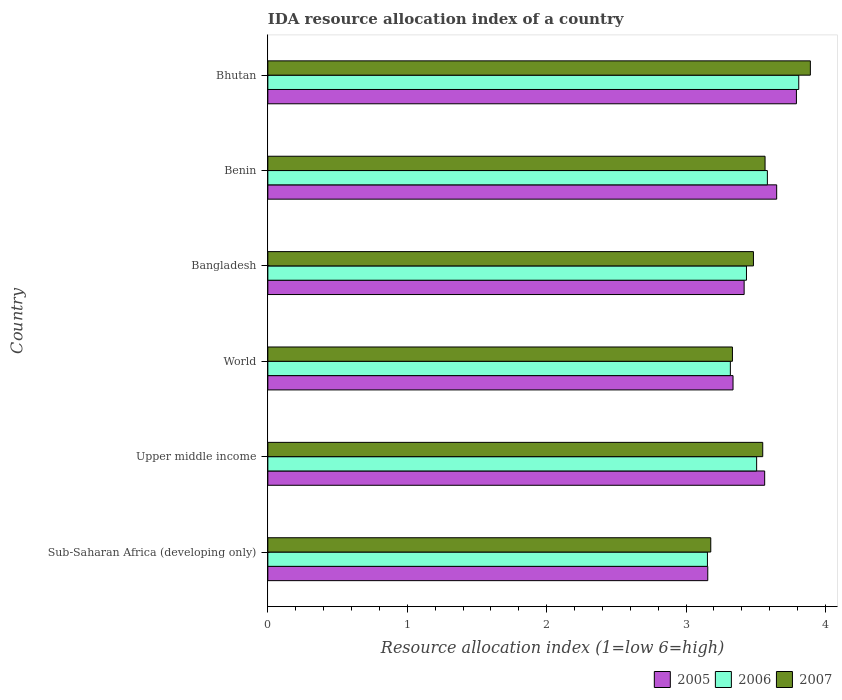Are the number of bars per tick equal to the number of legend labels?
Give a very brief answer. Yes. How many bars are there on the 5th tick from the top?
Make the answer very short. 3. How many bars are there on the 3rd tick from the bottom?
Give a very brief answer. 3. What is the label of the 5th group of bars from the top?
Make the answer very short. Upper middle income. In how many cases, is the number of bars for a given country not equal to the number of legend labels?
Give a very brief answer. 0. What is the IDA resource allocation index in 2006 in World?
Your response must be concise. 3.32. Across all countries, what is the maximum IDA resource allocation index in 2007?
Your answer should be very brief. 3.89. Across all countries, what is the minimum IDA resource allocation index in 2005?
Your response must be concise. 3.16. In which country was the IDA resource allocation index in 2007 maximum?
Your answer should be very brief. Bhutan. In which country was the IDA resource allocation index in 2005 minimum?
Provide a succinct answer. Sub-Saharan Africa (developing only). What is the total IDA resource allocation index in 2006 in the graph?
Provide a succinct answer. 20.8. What is the difference between the IDA resource allocation index in 2007 in Bhutan and that in Upper middle income?
Offer a terse response. 0.34. What is the difference between the IDA resource allocation index in 2005 in Benin and the IDA resource allocation index in 2007 in World?
Your answer should be very brief. 0.32. What is the average IDA resource allocation index in 2005 per country?
Your answer should be compact. 3.49. What is the difference between the IDA resource allocation index in 2006 and IDA resource allocation index in 2005 in Benin?
Provide a short and direct response. -0.07. What is the ratio of the IDA resource allocation index in 2007 in Bangladesh to that in Upper middle income?
Keep it short and to the point. 0.98. Is the IDA resource allocation index in 2005 in Bhutan less than that in World?
Provide a short and direct response. No. Is the difference between the IDA resource allocation index in 2006 in Benin and Bhutan greater than the difference between the IDA resource allocation index in 2005 in Benin and Bhutan?
Your response must be concise. No. What is the difference between the highest and the second highest IDA resource allocation index in 2006?
Your answer should be compact. 0.23. What is the difference between the highest and the lowest IDA resource allocation index in 2006?
Ensure brevity in your answer.  0.65. In how many countries, is the IDA resource allocation index in 2007 greater than the average IDA resource allocation index in 2007 taken over all countries?
Ensure brevity in your answer.  3. Is the sum of the IDA resource allocation index in 2007 in Sub-Saharan Africa (developing only) and Upper middle income greater than the maximum IDA resource allocation index in 2005 across all countries?
Keep it short and to the point. Yes. Is it the case that in every country, the sum of the IDA resource allocation index in 2005 and IDA resource allocation index in 2007 is greater than the IDA resource allocation index in 2006?
Keep it short and to the point. Yes. How many countries are there in the graph?
Provide a short and direct response. 6. Are the values on the major ticks of X-axis written in scientific E-notation?
Offer a very short reply. No. What is the title of the graph?
Your response must be concise. IDA resource allocation index of a country. What is the label or title of the X-axis?
Provide a succinct answer. Resource allocation index (1=low 6=high). What is the Resource allocation index (1=low 6=high) in 2005 in Sub-Saharan Africa (developing only)?
Your answer should be very brief. 3.16. What is the Resource allocation index (1=low 6=high) of 2006 in Sub-Saharan Africa (developing only)?
Provide a succinct answer. 3.15. What is the Resource allocation index (1=low 6=high) of 2007 in Sub-Saharan Africa (developing only)?
Offer a very short reply. 3.18. What is the Resource allocation index (1=low 6=high) of 2005 in Upper middle income?
Your answer should be compact. 3.56. What is the Resource allocation index (1=low 6=high) in 2006 in Upper middle income?
Ensure brevity in your answer.  3.51. What is the Resource allocation index (1=low 6=high) in 2007 in Upper middle income?
Offer a terse response. 3.55. What is the Resource allocation index (1=low 6=high) of 2005 in World?
Your answer should be compact. 3.34. What is the Resource allocation index (1=low 6=high) in 2006 in World?
Your answer should be very brief. 3.32. What is the Resource allocation index (1=low 6=high) of 2007 in World?
Your response must be concise. 3.33. What is the Resource allocation index (1=low 6=high) in 2005 in Bangladesh?
Make the answer very short. 3.42. What is the Resource allocation index (1=low 6=high) of 2006 in Bangladesh?
Provide a succinct answer. 3.43. What is the Resource allocation index (1=low 6=high) in 2007 in Bangladesh?
Your answer should be compact. 3.48. What is the Resource allocation index (1=low 6=high) of 2005 in Benin?
Give a very brief answer. 3.65. What is the Resource allocation index (1=low 6=high) of 2006 in Benin?
Your answer should be very brief. 3.58. What is the Resource allocation index (1=low 6=high) in 2007 in Benin?
Give a very brief answer. 3.57. What is the Resource allocation index (1=low 6=high) in 2005 in Bhutan?
Your response must be concise. 3.79. What is the Resource allocation index (1=low 6=high) of 2006 in Bhutan?
Your response must be concise. 3.81. What is the Resource allocation index (1=low 6=high) of 2007 in Bhutan?
Your answer should be compact. 3.89. Across all countries, what is the maximum Resource allocation index (1=low 6=high) in 2005?
Provide a succinct answer. 3.79. Across all countries, what is the maximum Resource allocation index (1=low 6=high) of 2006?
Offer a very short reply. 3.81. Across all countries, what is the maximum Resource allocation index (1=low 6=high) of 2007?
Keep it short and to the point. 3.89. Across all countries, what is the minimum Resource allocation index (1=low 6=high) in 2005?
Your answer should be compact. 3.16. Across all countries, what is the minimum Resource allocation index (1=low 6=high) in 2006?
Provide a short and direct response. 3.15. Across all countries, what is the minimum Resource allocation index (1=low 6=high) of 2007?
Offer a terse response. 3.18. What is the total Resource allocation index (1=low 6=high) of 2005 in the graph?
Offer a terse response. 20.91. What is the total Resource allocation index (1=low 6=high) in 2006 in the graph?
Ensure brevity in your answer.  20.8. What is the total Resource allocation index (1=low 6=high) in 2007 in the graph?
Offer a terse response. 21. What is the difference between the Resource allocation index (1=low 6=high) in 2005 in Sub-Saharan Africa (developing only) and that in Upper middle income?
Give a very brief answer. -0.41. What is the difference between the Resource allocation index (1=low 6=high) of 2006 in Sub-Saharan Africa (developing only) and that in Upper middle income?
Give a very brief answer. -0.35. What is the difference between the Resource allocation index (1=low 6=high) of 2007 in Sub-Saharan Africa (developing only) and that in Upper middle income?
Give a very brief answer. -0.37. What is the difference between the Resource allocation index (1=low 6=high) of 2005 in Sub-Saharan Africa (developing only) and that in World?
Your answer should be very brief. -0.18. What is the difference between the Resource allocation index (1=low 6=high) in 2006 in Sub-Saharan Africa (developing only) and that in World?
Your answer should be very brief. -0.16. What is the difference between the Resource allocation index (1=low 6=high) of 2007 in Sub-Saharan Africa (developing only) and that in World?
Your answer should be compact. -0.16. What is the difference between the Resource allocation index (1=low 6=high) of 2005 in Sub-Saharan Africa (developing only) and that in Bangladesh?
Keep it short and to the point. -0.26. What is the difference between the Resource allocation index (1=low 6=high) of 2006 in Sub-Saharan Africa (developing only) and that in Bangladesh?
Your answer should be very brief. -0.28. What is the difference between the Resource allocation index (1=low 6=high) in 2007 in Sub-Saharan Africa (developing only) and that in Bangladesh?
Your answer should be very brief. -0.31. What is the difference between the Resource allocation index (1=low 6=high) of 2005 in Sub-Saharan Africa (developing only) and that in Benin?
Your answer should be compact. -0.49. What is the difference between the Resource allocation index (1=low 6=high) in 2006 in Sub-Saharan Africa (developing only) and that in Benin?
Your answer should be very brief. -0.43. What is the difference between the Resource allocation index (1=low 6=high) of 2007 in Sub-Saharan Africa (developing only) and that in Benin?
Give a very brief answer. -0.39. What is the difference between the Resource allocation index (1=low 6=high) of 2005 in Sub-Saharan Africa (developing only) and that in Bhutan?
Ensure brevity in your answer.  -0.64. What is the difference between the Resource allocation index (1=low 6=high) in 2006 in Sub-Saharan Africa (developing only) and that in Bhutan?
Give a very brief answer. -0.66. What is the difference between the Resource allocation index (1=low 6=high) in 2007 in Sub-Saharan Africa (developing only) and that in Bhutan?
Provide a short and direct response. -0.71. What is the difference between the Resource allocation index (1=low 6=high) of 2005 in Upper middle income and that in World?
Keep it short and to the point. 0.23. What is the difference between the Resource allocation index (1=low 6=high) in 2006 in Upper middle income and that in World?
Provide a succinct answer. 0.19. What is the difference between the Resource allocation index (1=low 6=high) of 2007 in Upper middle income and that in World?
Ensure brevity in your answer.  0.22. What is the difference between the Resource allocation index (1=low 6=high) of 2005 in Upper middle income and that in Bangladesh?
Provide a succinct answer. 0.15. What is the difference between the Resource allocation index (1=low 6=high) of 2006 in Upper middle income and that in Bangladesh?
Ensure brevity in your answer.  0.07. What is the difference between the Resource allocation index (1=low 6=high) in 2007 in Upper middle income and that in Bangladesh?
Provide a succinct answer. 0.07. What is the difference between the Resource allocation index (1=low 6=high) of 2005 in Upper middle income and that in Benin?
Provide a short and direct response. -0.09. What is the difference between the Resource allocation index (1=low 6=high) of 2006 in Upper middle income and that in Benin?
Your response must be concise. -0.08. What is the difference between the Resource allocation index (1=low 6=high) of 2007 in Upper middle income and that in Benin?
Give a very brief answer. -0.02. What is the difference between the Resource allocation index (1=low 6=high) of 2005 in Upper middle income and that in Bhutan?
Your answer should be compact. -0.23. What is the difference between the Resource allocation index (1=low 6=high) of 2006 in Upper middle income and that in Bhutan?
Ensure brevity in your answer.  -0.3. What is the difference between the Resource allocation index (1=low 6=high) of 2007 in Upper middle income and that in Bhutan?
Your answer should be very brief. -0.34. What is the difference between the Resource allocation index (1=low 6=high) of 2005 in World and that in Bangladesh?
Give a very brief answer. -0.08. What is the difference between the Resource allocation index (1=low 6=high) in 2006 in World and that in Bangladesh?
Your answer should be very brief. -0.12. What is the difference between the Resource allocation index (1=low 6=high) in 2007 in World and that in Bangladesh?
Provide a succinct answer. -0.15. What is the difference between the Resource allocation index (1=low 6=high) in 2005 in World and that in Benin?
Your answer should be very brief. -0.31. What is the difference between the Resource allocation index (1=low 6=high) of 2006 in World and that in Benin?
Give a very brief answer. -0.27. What is the difference between the Resource allocation index (1=low 6=high) in 2007 in World and that in Benin?
Offer a terse response. -0.23. What is the difference between the Resource allocation index (1=low 6=high) of 2005 in World and that in Bhutan?
Provide a succinct answer. -0.45. What is the difference between the Resource allocation index (1=low 6=high) in 2006 in World and that in Bhutan?
Offer a terse response. -0.49. What is the difference between the Resource allocation index (1=low 6=high) of 2007 in World and that in Bhutan?
Give a very brief answer. -0.56. What is the difference between the Resource allocation index (1=low 6=high) of 2005 in Bangladesh and that in Benin?
Provide a short and direct response. -0.23. What is the difference between the Resource allocation index (1=low 6=high) of 2007 in Bangladesh and that in Benin?
Your answer should be compact. -0.08. What is the difference between the Resource allocation index (1=low 6=high) of 2005 in Bangladesh and that in Bhutan?
Ensure brevity in your answer.  -0.38. What is the difference between the Resource allocation index (1=low 6=high) in 2006 in Bangladesh and that in Bhutan?
Keep it short and to the point. -0.38. What is the difference between the Resource allocation index (1=low 6=high) of 2007 in Bangladesh and that in Bhutan?
Keep it short and to the point. -0.41. What is the difference between the Resource allocation index (1=low 6=high) of 2005 in Benin and that in Bhutan?
Provide a short and direct response. -0.14. What is the difference between the Resource allocation index (1=low 6=high) of 2006 in Benin and that in Bhutan?
Your answer should be compact. -0.23. What is the difference between the Resource allocation index (1=low 6=high) in 2007 in Benin and that in Bhutan?
Offer a very short reply. -0.33. What is the difference between the Resource allocation index (1=low 6=high) of 2005 in Sub-Saharan Africa (developing only) and the Resource allocation index (1=low 6=high) of 2006 in Upper middle income?
Provide a succinct answer. -0.35. What is the difference between the Resource allocation index (1=low 6=high) in 2005 in Sub-Saharan Africa (developing only) and the Resource allocation index (1=low 6=high) in 2007 in Upper middle income?
Keep it short and to the point. -0.39. What is the difference between the Resource allocation index (1=low 6=high) of 2006 in Sub-Saharan Africa (developing only) and the Resource allocation index (1=low 6=high) of 2007 in Upper middle income?
Keep it short and to the point. -0.4. What is the difference between the Resource allocation index (1=low 6=high) of 2005 in Sub-Saharan Africa (developing only) and the Resource allocation index (1=low 6=high) of 2006 in World?
Provide a succinct answer. -0.16. What is the difference between the Resource allocation index (1=low 6=high) of 2005 in Sub-Saharan Africa (developing only) and the Resource allocation index (1=low 6=high) of 2007 in World?
Ensure brevity in your answer.  -0.18. What is the difference between the Resource allocation index (1=low 6=high) in 2006 in Sub-Saharan Africa (developing only) and the Resource allocation index (1=low 6=high) in 2007 in World?
Your answer should be very brief. -0.18. What is the difference between the Resource allocation index (1=low 6=high) in 2005 in Sub-Saharan Africa (developing only) and the Resource allocation index (1=low 6=high) in 2006 in Bangladesh?
Your answer should be very brief. -0.28. What is the difference between the Resource allocation index (1=low 6=high) of 2005 in Sub-Saharan Africa (developing only) and the Resource allocation index (1=low 6=high) of 2007 in Bangladesh?
Make the answer very short. -0.33. What is the difference between the Resource allocation index (1=low 6=high) in 2006 in Sub-Saharan Africa (developing only) and the Resource allocation index (1=low 6=high) in 2007 in Bangladesh?
Keep it short and to the point. -0.33. What is the difference between the Resource allocation index (1=low 6=high) in 2005 in Sub-Saharan Africa (developing only) and the Resource allocation index (1=low 6=high) in 2006 in Benin?
Ensure brevity in your answer.  -0.43. What is the difference between the Resource allocation index (1=low 6=high) of 2005 in Sub-Saharan Africa (developing only) and the Resource allocation index (1=low 6=high) of 2007 in Benin?
Offer a terse response. -0.41. What is the difference between the Resource allocation index (1=low 6=high) in 2006 in Sub-Saharan Africa (developing only) and the Resource allocation index (1=low 6=high) in 2007 in Benin?
Provide a succinct answer. -0.41. What is the difference between the Resource allocation index (1=low 6=high) of 2005 in Sub-Saharan Africa (developing only) and the Resource allocation index (1=low 6=high) of 2006 in Bhutan?
Provide a succinct answer. -0.65. What is the difference between the Resource allocation index (1=low 6=high) in 2005 in Sub-Saharan Africa (developing only) and the Resource allocation index (1=low 6=high) in 2007 in Bhutan?
Your response must be concise. -0.74. What is the difference between the Resource allocation index (1=low 6=high) in 2006 in Sub-Saharan Africa (developing only) and the Resource allocation index (1=low 6=high) in 2007 in Bhutan?
Provide a succinct answer. -0.74. What is the difference between the Resource allocation index (1=low 6=high) of 2005 in Upper middle income and the Resource allocation index (1=low 6=high) of 2006 in World?
Provide a short and direct response. 0.25. What is the difference between the Resource allocation index (1=low 6=high) of 2005 in Upper middle income and the Resource allocation index (1=low 6=high) of 2007 in World?
Provide a short and direct response. 0.23. What is the difference between the Resource allocation index (1=low 6=high) of 2006 in Upper middle income and the Resource allocation index (1=low 6=high) of 2007 in World?
Your answer should be compact. 0.17. What is the difference between the Resource allocation index (1=low 6=high) of 2005 in Upper middle income and the Resource allocation index (1=low 6=high) of 2006 in Bangladesh?
Your answer should be compact. 0.13. What is the difference between the Resource allocation index (1=low 6=high) of 2005 in Upper middle income and the Resource allocation index (1=low 6=high) of 2007 in Bangladesh?
Your answer should be compact. 0.08. What is the difference between the Resource allocation index (1=low 6=high) of 2006 in Upper middle income and the Resource allocation index (1=low 6=high) of 2007 in Bangladesh?
Ensure brevity in your answer.  0.02. What is the difference between the Resource allocation index (1=low 6=high) of 2005 in Upper middle income and the Resource allocation index (1=low 6=high) of 2006 in Benin?
Your response must be concise. -0.02. What is the difference between the Resource allocation index (1=low 6=high) of 2005 in Upper middle income and the Resource allocation index (1=low 6=high) of 2007 in Benin?
Offer a terse response. -0. What is the difference between the Resource allocation index (1=low 6=high) in 2006 in Upper middle income and the Resource allocation index (1=low 6=high) in 2007 in Benin?
Your response must be concise. -0.06. What is the difference between the Resource allocation index (1=low 6=high) in 2005 in Upper middle income and the Resource allocation index (1=low 6=high) in 2006 in Bhutan?
Your answer should be very brief. -0.24. What is the difference between the Resource allocation index (1=low 6=high) in 2005 in Upper middle income and the Resource allocation index (1=low 6=high) in 2007 in Bhutan?
Give a very brief answer. -0.33. What is the difference between the Resource allocation index (1=low 6=high) in 2006 in Upper middle income and the Resource allocation index (1=low 6=high) in 2007 in Bhutan?
Make the answer very short. -0.39. What is the difference between the Resource allocation index (1=low 6=high) of 2005 in World and the Resource allocation index (1=low 6=high) of 2006 in Bangladesh?
Make the answer very short. -0.1. What is the difference between the Resource allocation index (1=low 6=high) in 2005 in World and the Resource allocation index (1=low 6=high) in 2007 in Bangladesh?
Give a very brief answer. -0.15. What is the difference between the Resource allocation index (1=low 6=high) in 2006 in World and the Resource allocation index (1=low 6=high) in 2007 in Bangladesh?
Make the answer very short. -0.17. What is the difference between the Resource allocation index (1=low 6=high) in 2005 in World and the Resource allocation index (1=low 6=high) in 2006 in Benin?
Ensure brevity in your answer.  -0.25. What is the difference between the Resource allocation index (1=low 6=high) of 2005 in World and the Resource allocation index (1=low 6=high) of 2007 in Benin?
Your answer should be very brief. -0.23. What is the difference between the Resource allocation index (1=low 6=high) in 2006 in World and the Resource allocation index (1=low 6=high) in 2007 in Benin?
Ensure brevity in your answer.  -0.25. What is the difference between the Resource allocation index (1=low 6=high) in 2005 in World and the Resource allocation index (1=low 6=high) in 2006 in Bhutan?
Make the answer very short. -0.47. What is the difference between the Resource allocation index (1=low 6=high) of 2005 in World and the Resource allocation index (1=low 6=high) of 2007 in Bhutan?
Offer a terse response. -0.55. What is the difference between the Resource allocation index (1=low 6=high) of 2006 in World and the Resource allocation index (1=low 6=high) of 2007 in Bhutan?
Make the answer very short. -0.57. What is the difference between the Resource allocation index (1=low 6=high) of 2006 in Bangladesh and the Resource allocation index (1=low 6=high) of 2007 in Benin?
Your response must be concise. -0.13. What is the difference between the Resource allocation index (1=low 6=high) of 2005 in Bangladesh and the Resource allocation index (1=low 6=high) of 2006 in Bhutan?
Provide a succinct answer. -0.39. What is the difference between the Resource allocation index (1=low 6=high) of 2005 in Bangladesh and the Resource allocation index (1=low 6=high) of 2007 in Bhutan?
Offer a very short reply. -0.47. What is the difference between the Resource allocation index (1=low 6=high) in 2006 in Bangladesh and the Resource allocation index (1=low 6=high) in 2007 in Bhutan?
Make the answer very short. -0.46. What is the difference between the Resource allocation index (1=low 6=high) in 2005 in Benin and the Resource allocation index (1=low 6=high) in 2006 in Bhutan?
Your response must be concise. -0.16. What is the difference between the Resource allocation index (1=low 6=high) in 2005 in Benin and the Resource allocation index (1=low 6=high) in 2007 in Bhutan?
Your response must be concise. -0.24. What is the difference between the Resource allocation index (1=low 6=high) in 2006 in Benin and the Resource allocation index (1=low 6=high) in 2007 in Bhutan?
Your response must be concise. -0.31. What is the average Resource allocation index (1=low 6=high) in 2005 per country?
Offer a very short reply. 3.49. What is the average Resource allocation index (1=low 6=high) of 2006 per country?
Give a very brief answer. 3.47. What is the average Resource allocation index (1=low 6=high) of 2007 per country?
Make the answer very short. 3.5. What is the difference between the Resource allocation index (1=low 6=high) in 2005 and Resource allocation index (1=low 6=high) in 2006 in Sub-Saharan Africa (developing only)?
Ensure brevity in your answer.  0. What is the difference between the Resource allocation index (1=low 6=high) in 2005 and Resource allocation index (1=low 6=high) in 2007 in Sub-Saharan Africa (developing only)?
Keep it short and to the point. -0.02. What is the difference between the Resource allocation index (1=low 6=high) of 2006 and Resource allocation index (1=low 6=high) of 2007 in Sub-Saharan Africa (developing only)?
Ensure brevity in your answer.  -0.02. What is the difference between the Resource allocation index (1=low 6=high) of 2005 and Resource allocation index (1=low 6=high) of 2006 in Upper middle income?
Your answer should be very brief. 0.06. What is the difference between the Resource allocation index (1=low 6=high) in 2005 and Resource allocation index (1=low 6=high) in 2007 in Upper middle income?
Your response must be concise. 0.01. What is the difference between the Resource allocation index (1=low 6=high) of 2006 and Resource allocation index (1=low 6=high) of 2007 in Upper middle income?
Make the answer very short. -0.04. What is the difference between the Resource allocation index (1=low 6=high) in 2005 and Resource allocation index (1=low 6=high) in 2006 in World?
Ensure brevity in your answer.  0.02. What is the difference between the Resource allocation index (1=low 6=high) in 2005 and Resource allocation index (1=low 6=high) in 2007 in World?
Your answer should be very brief. 0. What is the difference between the Resource allocation index (1=low 6=high) of 2006 and Resource allocation index (1=low 6=high) of 2007 in World?
Provide a succinct answer. -0.01. What is the difference between the Resource allocation index (1=low 6=high) in 2005 and Resource allocation index (1=low 6=high) in 2006 in Bangladesh?
Provide a short and direct response. -0.02. What is the difference between the Resource allocation index (1=low 6=high) in 2005 and Resource allocation index (1=low 6=high) in 2007 in Bangladesh?
Your response must be concise. -0.07. What is the difference between the Resource allocation index (1=low 6=high) of 2005 and Resource allocation index (1=low 6=high) of 2006 in Benin?
Provide a short and direct response. 0.07. What is the difference between the Resource allocation index (1=low 6=high) in 2005 and Resource allocation index (1=low 6=high) in 2007 in Benin?
Provide a succinct answer. 0.08. What is the difference between the Resource allocation index (1=low 6=high) of 2006 and Resource allocation index (1=low 6=high) of 2007 in Benin?
Give a very brief answer. 0.02. What is the difference between the Resource allocation index (1=low 6=high) of 2005 and Resource allocation index (1=low 6=high) of 2006 in Bhutan?
Provide a succinct answer. -0.02. What is the difference between the Resource allocation index (1=low 6=high) of 2006 and Resource allocation index (1=low 6=high) of 2007 in Bhutan?
Give a very brief answer. -0.08. What is the ratio of the Resource allocation index (1=low 6=high) of 2005 in Sub-Saharan Africa (developing only) to that in Upper middle income?
Offer a terse response. 0.89. What is the ratio of the Resource allocation index (1=low 6=high) in 2006 in Sub-Saharan Africa (developing only) to that in Upper middle income?
Provide a succinct answer. 0.9. What is the ratio of the Resource allocation index (1=low 6=high) in 2007 in Sub-Saharan Africa (developing only) to that in Upper middle income?
Offer a very short reply. 0.9. What is the ratio of the Resource allocation index (1=low 6=high) of 2005 in Sub-Saharan Africa (developing only) to that in World?
Your response must be concise. 0.95. What is the ratio of the Resource allocation index (1=low 6=high) of 2006 in Sub-Saharan Africa (developing only) to that in World?
Ensure brevity in your answer.  0.95. What is the ratio of the Resource allocation index (1=low 6=high) in 2007 in Sub-Saharan Africa (developing only) to that in World?
Provide a short and direct response. 0.95. What is the ratio of the Resource allocation index (1=low 6=high) in 2005 in Sub-Saharan Africa (developing only) to that in Bangladesh?
Provide a short and direct response. 0.92. What is the ratio of the Resource allocation index (1=low 6=high) in 2006 in Sub-Saharan Africa (developing only) to that in Bangladesh?
Provide a short and direct response. 0.92. What is the ratio of the Resource allocation index (1=low 6=high) of 2007 in Sub-Saharan Africa (developing only) to that in Bangladesh?
Give a very brief answer. 0.91. What is the ratio of the Resource allocation index (1=low 6=high) of 2005 in Sub-Saharan Africa (developing only) to that in Benin?
Keep it short and to the point. 0.86. What is the ratio of the Resource allocation index (1=low 6=high) of 2006 in Sub-Saharan Africa (developing only) to that in Benin?
Your answer should be compact. 0.88. What is the ratio of the Resource allocation index (1=low 6=high) in 2007 in Sub-Saharan Africa (developing only) to that in Benin?
Keep it short and to the point. 0.89. What is the ratio of the Resource allocation index (1=low 6=high) in 2005 in Sub-Saharan Africa (developing only) to that in Bhutan?
Provide a succinct answer. 0.83. What is the ratio of the Resource allocation index (1=low 6=high) in 2006 in Sub-Saharan Africa (developing only) to that in Bhutan?
Offer a very short reply. 0.83. What is the ratio of the Resource allocation index (1=low 6=high) in 2007 in Sub-Saharan Africa (developing only) to that in Bhutan?
Offer a terse response. 0.82. What is the ratio of the Resource allocation index (1=low 6=high) in 2005 in Upper middle income to that in World?
Give a very brief answer. 1.07. What is the ratio of the Resource allocation index (1=low 6=high) in 2006 in Upper middle income to that in World?
Ensure brevity in your answer.  1.06. What is the ratio of the Resource allocation index (1=low 6=high) of 2007 in Upper middle income to that in World?
Make the answer very short. 1.07. What is the ratio of the Resource allocation index (1=low 6=high) of 2005 in Upper middle income to that in Bangladesh?
Offer a terse response. 1.04. What is the ratio of the Resource allocation index (1=low 6=high) of 2006 in Upper middle income to that in Bangladesh?
Provide a succinct answer. 1.02. What is the ratio of the Resource allocation index (1=low 6=high) in 2007 in Upper middle income to that in Bangladesh?
Provide a succinct answer. 1.02. What is the ratio of the Resource allocation index (1=low 6=high) in 2005 in Upper middle income to that in Benin?
Give a very brief answer. 0.98. What is the ratio of the Resource allocation index (1=low 6=high) in 2006 in Upper middle income to that in Benin?
Give a very brief answer. 0.98. What is the ratio of the Resource allocation index (1=low 6=high) of 2005 in Upper middle income to that in Bhutan?
Keep it short and to the point. 0.94. What is the ratio of the Resource allocation index (1=low 6=high) of 2006 in Upper middle income to that in Bhutan?
Your answer should be very brief. 0.92. What is the ratio of the Resource allocation index (1=low 6=high) in 2007 in Upper middle income to that in Bhutan?
Provide a succinct answer. 0.91. What is the ratio of the Resource allocation index (1=low 6=high) in 2005 in World to that in Bangladesh?
Offer a terse response. 0.98. What is the ratio of the Resource allocation index (1=low 6=high) of 2006 in World to that in Bangladesh?
Provide a succinct answer. 0.97. What is the ratio of the Resource allocation index (1=low 6=high) in 2007 in World to that in Bangladesh?
Give a very brief answer. 0.96. What is the ratio of the Resource allocation index (1=low 6=high) of 2005 in World to that in Benin?
Offer a terse response. 0.91. What is the ratio of the Resource allocation index (1=low 6=high) of 2006 in World to that in Benin?
Your response must be concise. 0.93. What is the ratio of the Resource allocation index (1=low 6=high) of 2007 in World to that in Benin?
Make the answer very short. 0.93. What is the ratio of the Resource allocation index (1=low 6=high) in 2005 in World to that in Bhutan?
Your response must be concise. 0.88. What is the ratio of the Resource allocation index (1=low 6=high) in 2006 in World to that in Bhutan?
Provide a succinct answer. 0.87. What is the ratio of the Resource allocation index (1=low 6=high) of 2007 in World to that in Bhutan?
Give a very brief answer. 0.86. What is the ratio of the Resource allocation index (1=low 6=high) of 2005 in Bangladesh to that in Benin?
Give a very brief answer. 0.94. What is the ratio of the Resource allocation index (1=low 6=high) of 2006 in Bangladesh to that in Benin?
Provide a succinct answer. 0.96. What is the ratio of the Resource allocation index (1=low 6=high) in 2007 in Bangladesh to that in Benin?
Your answer should be very brief. 0.98. What is the ratio of the Resource allocation index (1=low 6=high) in 2005 in Bangladesh to that in Bhutan?
Ensure brevity in your answer.  0.9. What is the ratio of the Resource allocation index (1=low 6=high) of 2006 in Bangladesh to that in Bhutan?
Give a very brief answer. 0.9. What is the ratio of the Resource allocation index (1=low 6=high) of 2007 in Bangladesh to that in Bhutan?
Keep it short and to the point. 0.9. What is the ratio of the Resource allocation index (1=low 6=high) in 2005 in Benin to that in Bhutan?
Your answer should be very brief. 0.96. What is the ratio of the Resource allocation index (1=low 6=high) in 2006 in Benin to that in Bhutan?
Give a very brief answer. 0.94. What is the ratio of the Resource allocation index (1=low 6=high) in 2007 in Benin to that in Bhutan?
Your response must be concise. 0.92. What is the difference between the highest and the second highest Resource allocation index (1=low 6=high) of 2005?
Offer a terse response. 0.14. What is the difference between the highest and the second highest Resource allocation index (1=low 6=high) in 2006?
Provide a succinct answer. 0.23. What is the difference between the highest and the second highest Resource allocation index (1=low 6=high) in 2007?
Provide a short and direct response. 0.33. What is the difference between the highest and the lowest Resource allocation index (1=low 6=high) in 2005?
Your answer should be compact. 0.64. What is the difference between the highest and the lowest Resource allocation index (1=low 6=high) in 2006?
Your answer should be very brief. 0.66. What is the difference between the highest and the lowest Resource allocation index (1=low 6=high) of 2007?
Keep it short and to the point. 0.71. 